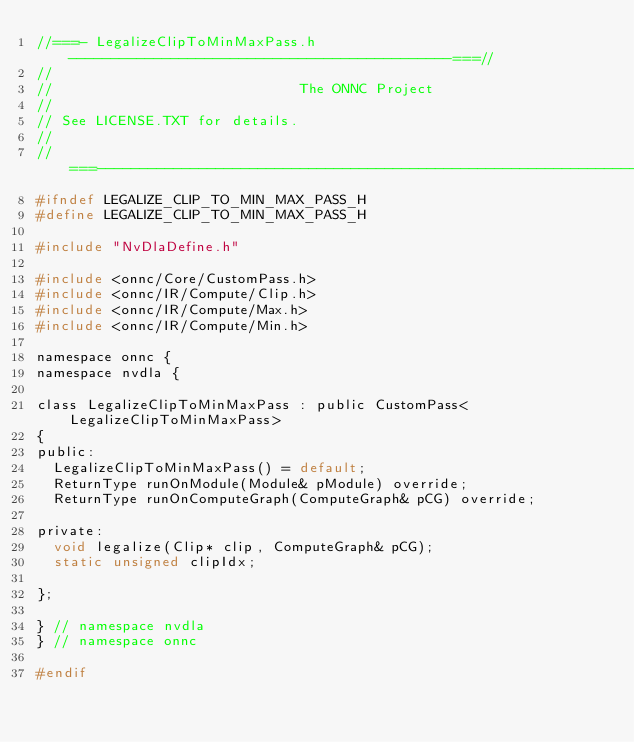Convert code to text. <code><loc_0><loc_0><loc_500><loc_500><_C_>//===- LegalizeClipToMinMaxPass.h ---------------------------------------------===//
//
//                             The ONNC Project
//
// See LICENSE.TXT for details.
//
//===----------------------------------------------------------------------===//
#ifndef LEGALIZE_CLIP_TO_MIN_MAX_PASS_H
#define LEGALIZE_CLIP_TO_MIN_MAX_PASS_H

#include "NvDlaDefine.h"

#include <onnc/Core/CustomPass.h>
#include <onnc/IR/Compute/Clip.h>
#include <onnc/IR/Compute/Max.h>
#include <onnc/IR/Compute/Min.h>

namespace onnc {
namespace nvdla {

class LegalizeClipToMinMaxPass : public CustomPass<LegalizeClipToMinMaxPass>
{
public:
  LegalizeClipToMinMaxPass() = default;
  ReturnType runOnModule(Module& pModule) override;
  ReturnType runOnComputeGraph(ComputeGraph& pCG) override;

private:
  void legalize(Clip* clip, ComputeGraph& pCG);
  static unsigned clipIdx;

};

} // namespace nvdla
} // namespace onnc

#endif
</code> 